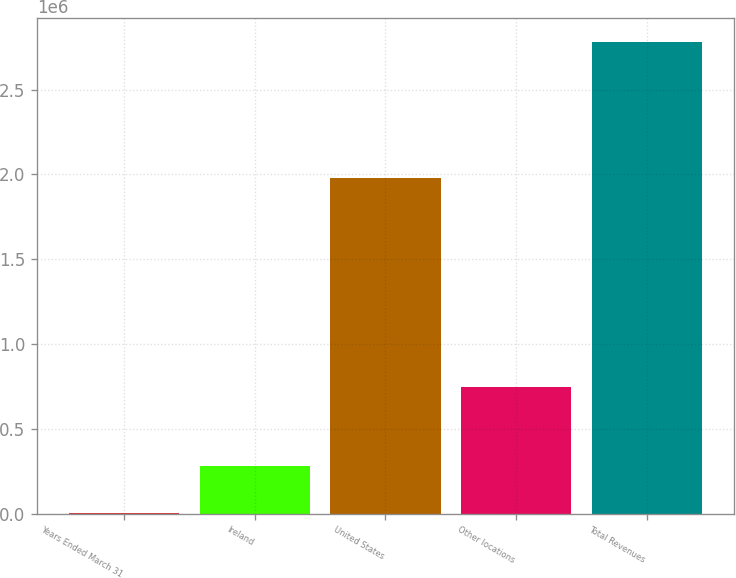<chart> <loc_0><loc_0><loc_500><loc_500><bar_chart><fcel>Years Ended March 31<fcel>Ireland<fcel>United States<fcel>Other locations<fcel>Total Revenues<nl><fcel>2019<fcel>280034<fcel>1.97681e+06<fcel>748572<fcel>2.78217e+06<nl></chart> 